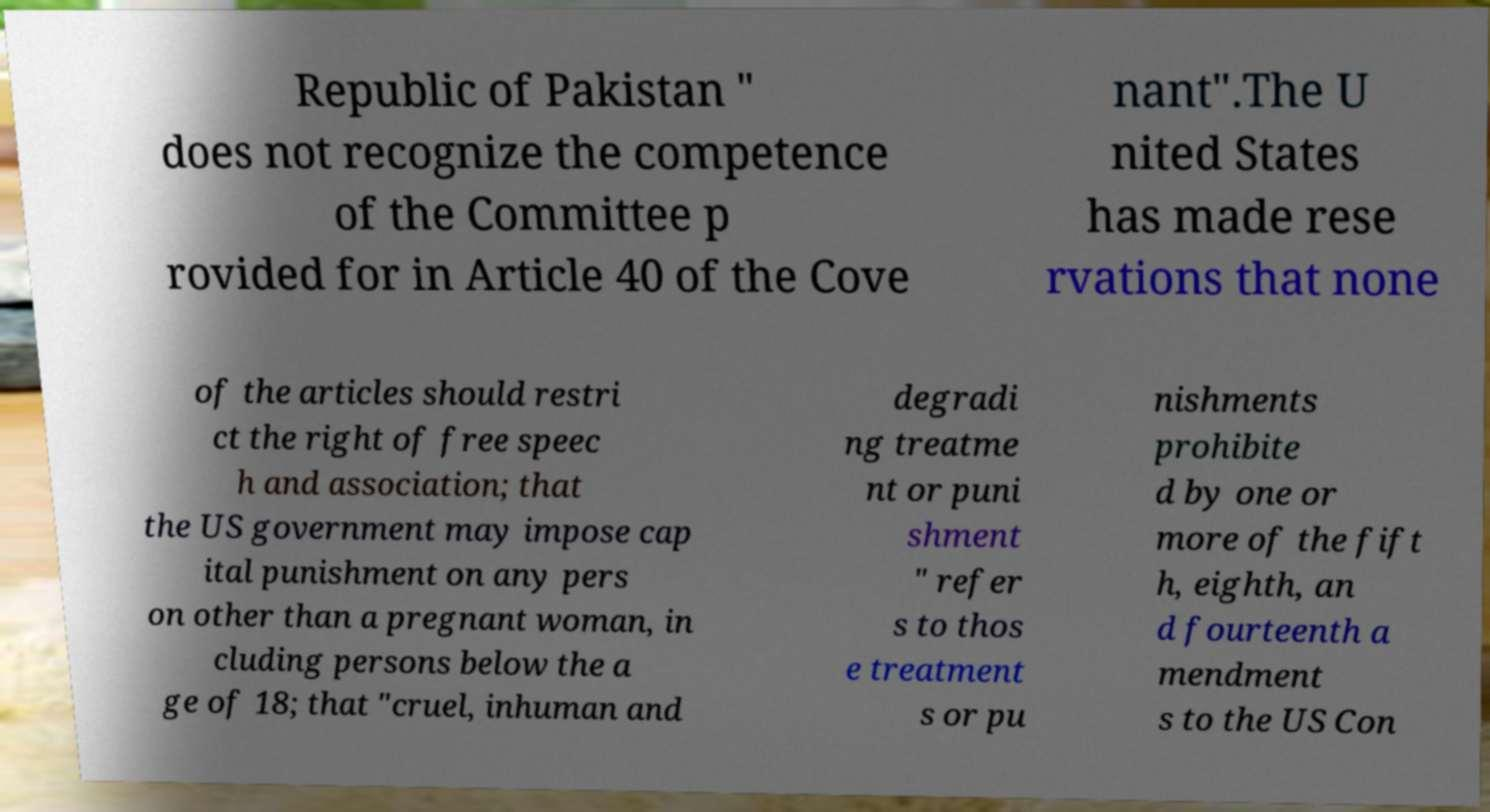For documentation purposes, I need the text within this image transcribed. Could you provide that? Republic of Pakistan " does not recognize the competence of the Committee p rovided for in Article 40 of the Cove nant".The U nited States has made rese rvations that none of the articles should restri ct the right of free speec h and association; that the US government may impose cap ital punishment on any pers on other than a pregnant woman, in cluding persons below the a ge of 18; that "cruel, inhuman and degradi ng treatme nt or puni shment " refer s to thos e treatment s or pu nishments prohibite d by one or more of the fift h, eighth, an d fourteenth a mendment s to the US Con 